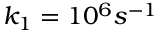<formula> <loc_0><loc_0><loc_500><loc_500>k _ { 1 } = 1 0 ^ { 6 } s ^ { - 1 }</formula> 